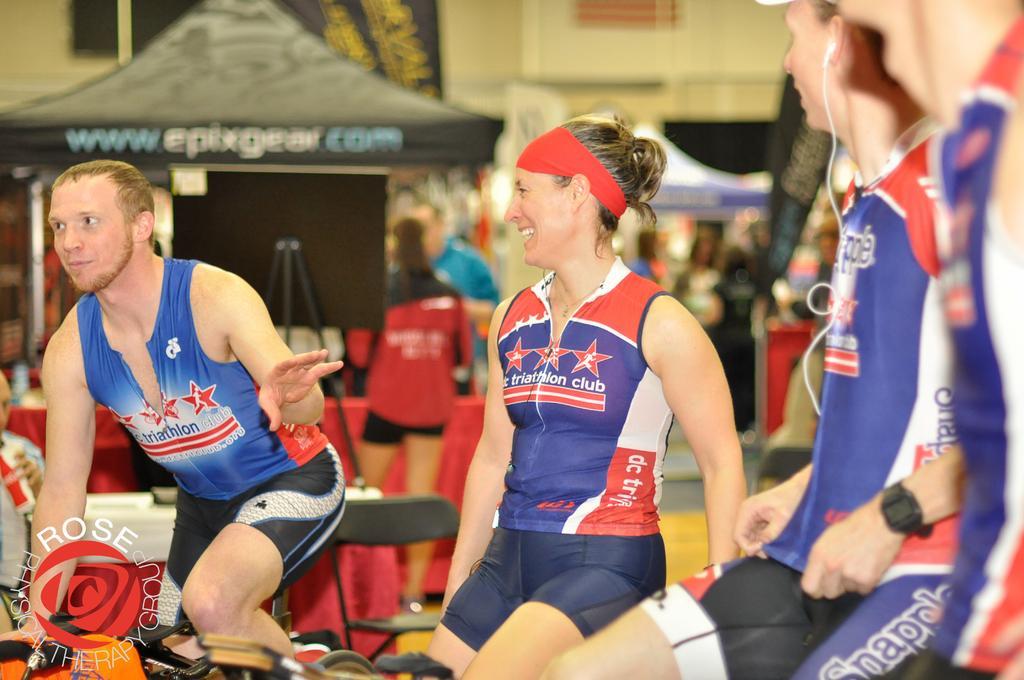In one or two sentences, can you explain what this image depicts? In the image there is a man on the left side cycling and beside him there are few persons sitting, they all wearing sports dress, in the back there is tent with some people standing in front of it. 